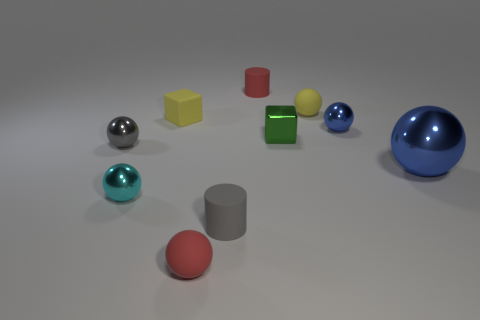There is a green cube that is to the right of the small cyan shiny object; what number of metal things are left of it?
Your answer should be very brief. 2. What shape is the gray metallic object that is on the left side of the gray cylinder?
Offer a terse response. Sphere. There is a red thing that is behind the small yellow object left of the cylinder that is behind the tiny green thing; what is its material?
Offer a very short reply. Rubber. How many other things are there of the same size as the yellow cube?
Your answer should be compact. 8. What is the material of the red object that is the same shape as the small gray rubber object?
Ensure brevity in your answer.  Rubber. What is the color of the matte cube?
Make the answer very short. Yellow. The small matte object left of the tiny red rubber object that is in front of the green object is what color?
Offer a terse response. Yellow. There is a big metallic object; is its color the same as the small metal thing on the right side of the tiny green metal thing?
Your answer should be compact. Yes. What number of small red things are in front of the small yellow matte ball that is in front of the tiny rubber object that is behind the yellow sphere?
Offer a very short reply. 1. There is a red rubber cylinder; are there any tiny rubber spheres left of it?
Your answer should be compact. Yes. 